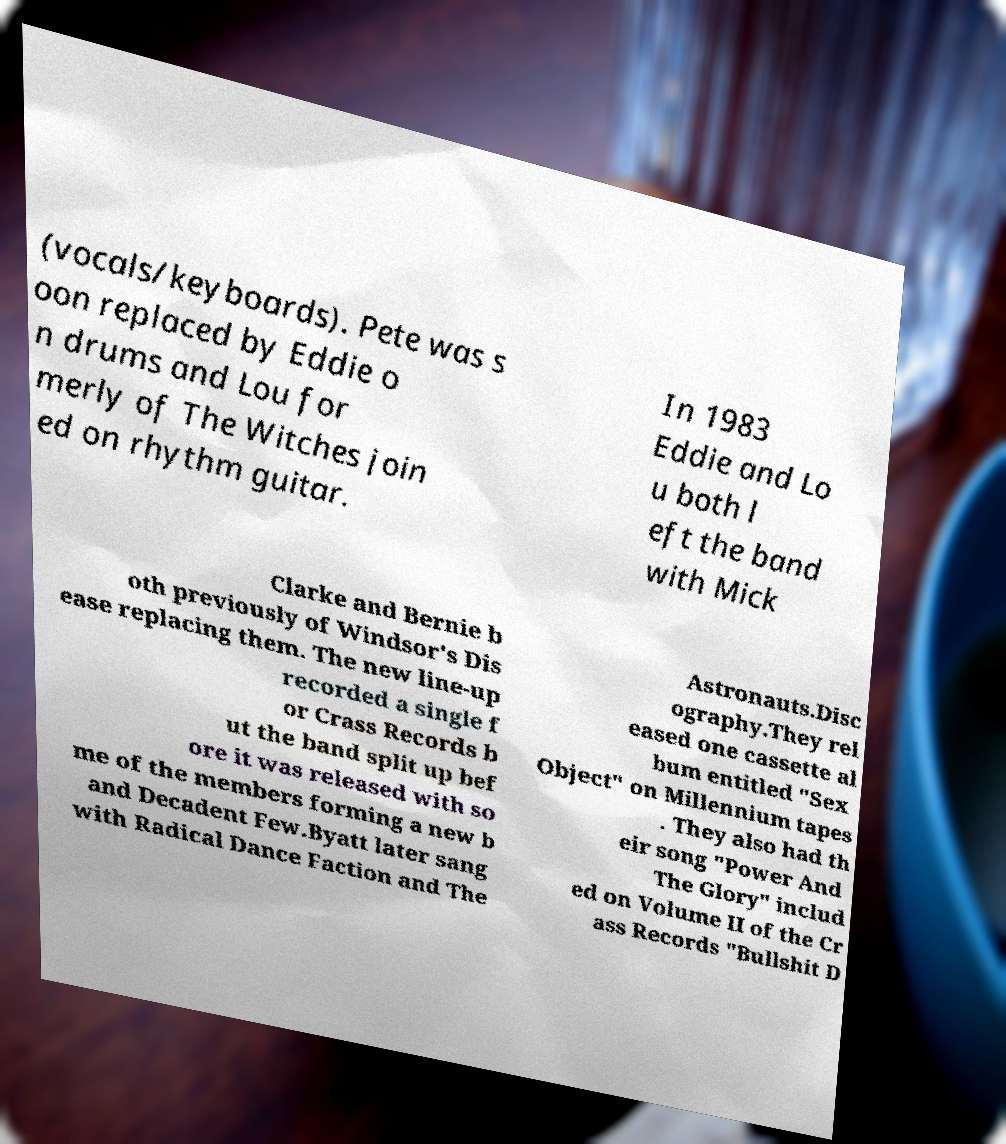Can you accurately transcribe the text from the provided image for me? (vocals/keyboards). Pete was s oon replaced by Eddie o n drums and Lou for merly of The Witches join ed on rhythm guitar. In 1983 Eddie and Lo u both l eft the band with Mick Clarke and Bernie b oth previously of Windsor's Dis ease replacing them. The new line-up recorded a single f or Crass Records b ut the band split up bef ore it was released with so me of the members forming a new b and Decadent Few.Byatt later sang with Radical Dance Faction and The Astronauts.Disc ography.They rel eased one cassette al bum entitled "Sex Object" on Millennium tapes . They also had th eir song "Power And The Glory" includ ed on Volume II of the Cr ass Records "Bullshit D 